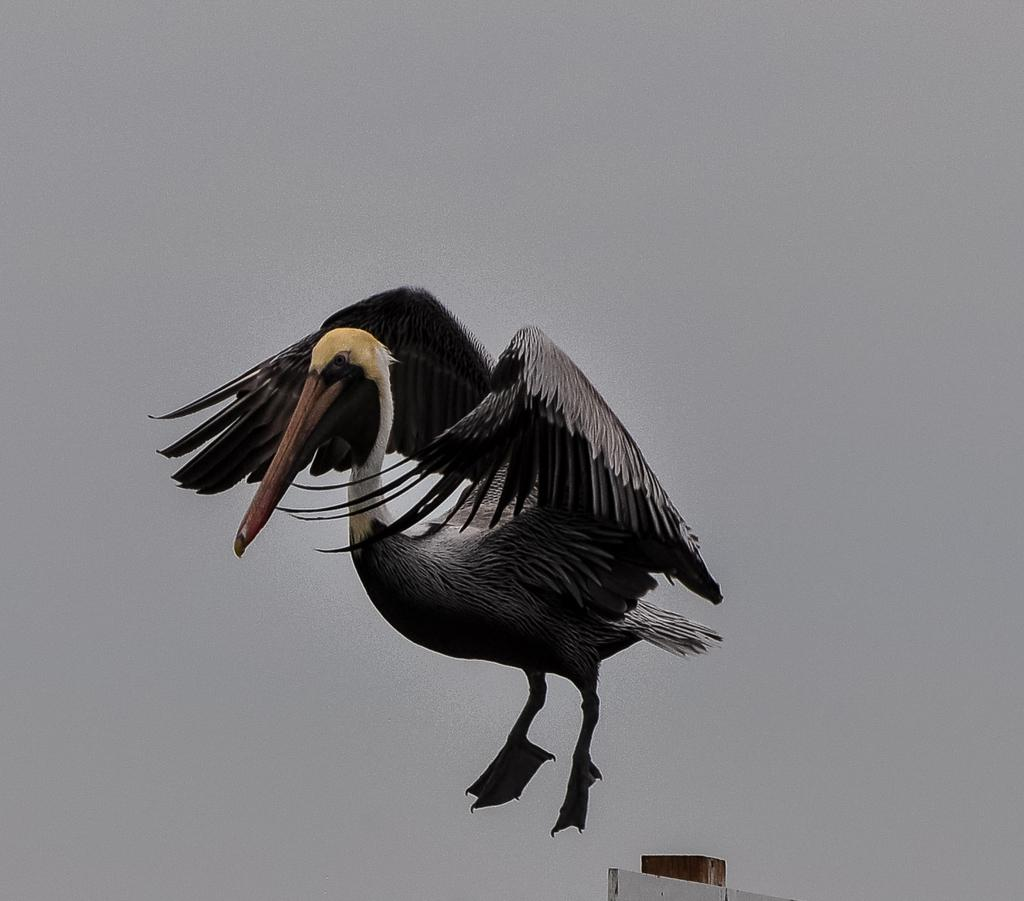What type of artwork is depicted in the image? The image is a painting. What is the main subject of the painting? There is a flying bird in the painting. What color is the bird in the painting? The bird is in grey color. What is at the bottom of the painting? There is a wall at the bottom of the painting. What is the overall color scheme of the painting? The background of the painting is in grey color. How many pizzas are being served in the painting? There are no pizzas present in the painting; it features a flying bird and a grey background. 